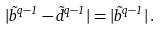Convert formula to latex. <formula><loc_0><loc_0><loc_500><loc_500>| \tilde { b } ^ { q - 1 } - \tilde { d } ^ { q - 1 } | = | \tilde { b } ^ { q - 1 } | \, .</formula> 